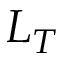Convert formula to latex. <formula><loc_0><loc_0><loc_500><loc_500>L _ { T }</formula> 